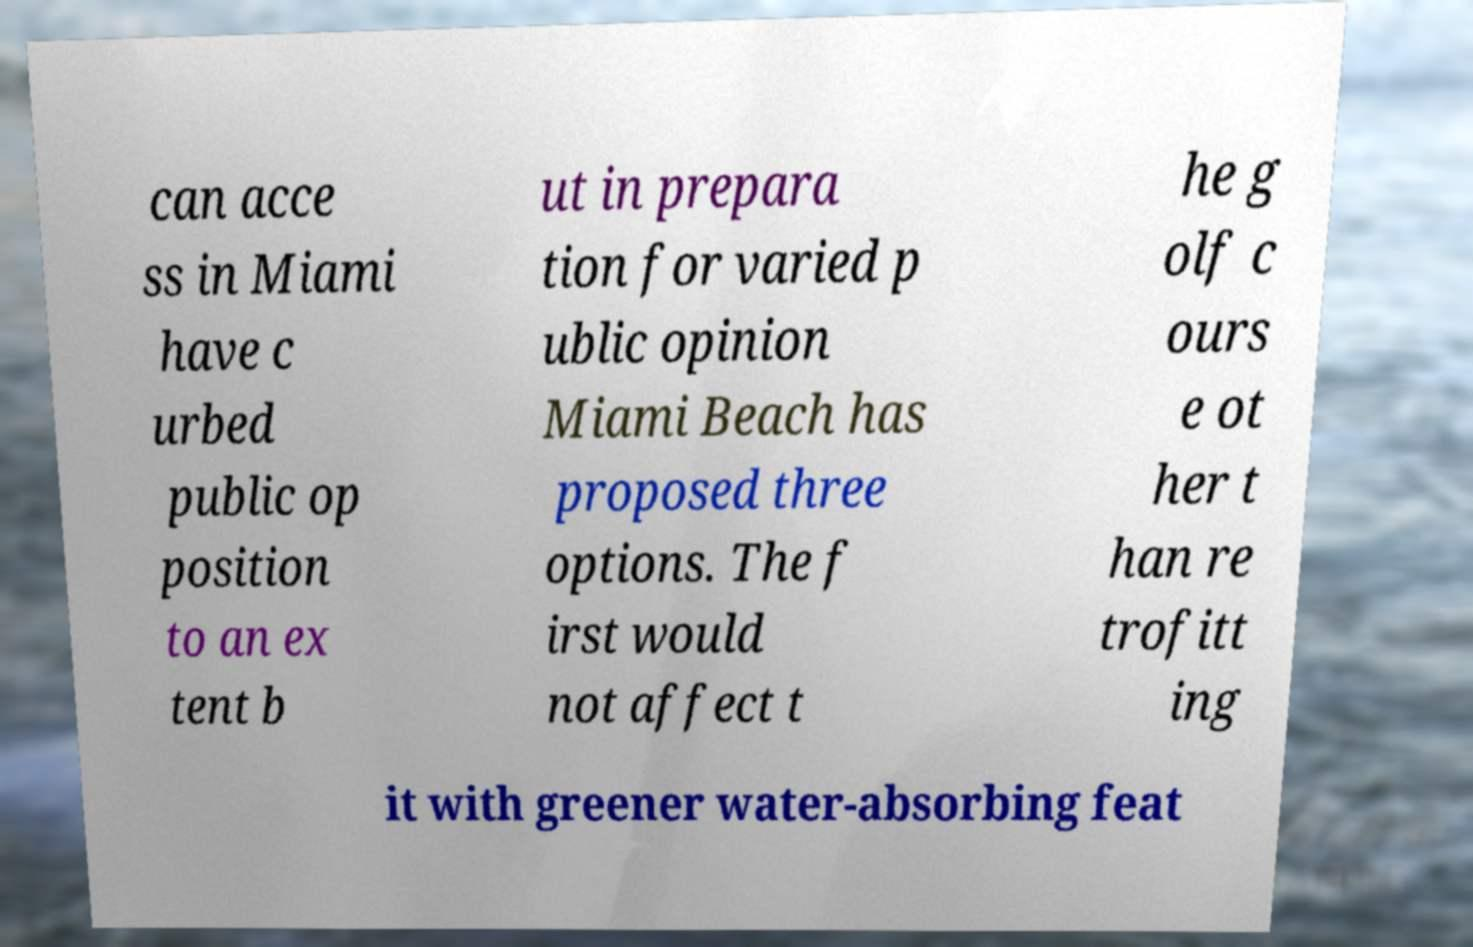I need the written content from this picture converted into text. Can you do that? can acce ss in Miami have c urbed public op position to an ex tent b ut in prepara tion for varied p ublic opinion Miami Beach has proposed three options. The f irst would not affect t he g olf c ours e ot her t han re trofitt ing it with greener water-absorbing feat 